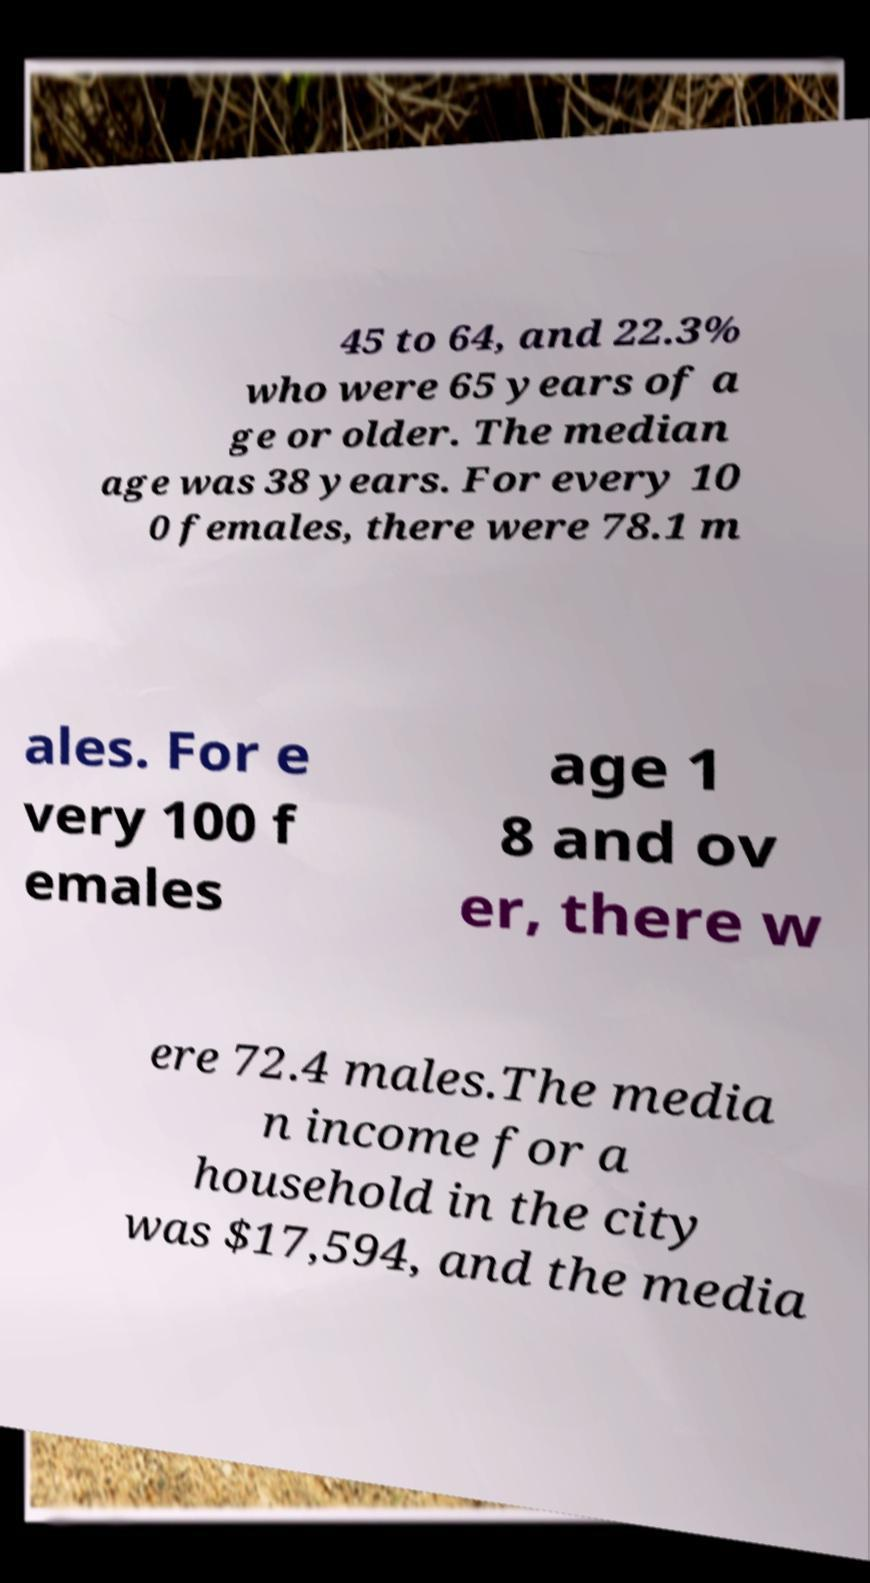What messages or text are displayed in this image? I need them in a readable, typed format. 45 to 64, and 22.3% who were 65 years of a ge or older. The median age was 38 years. For every 10 0 females, there were 78.1 m ales. For e very 100 f emales age 1 8 and ov er, there w ere 72.4 males.The media n income for a household in the city was $17,594, and the media 